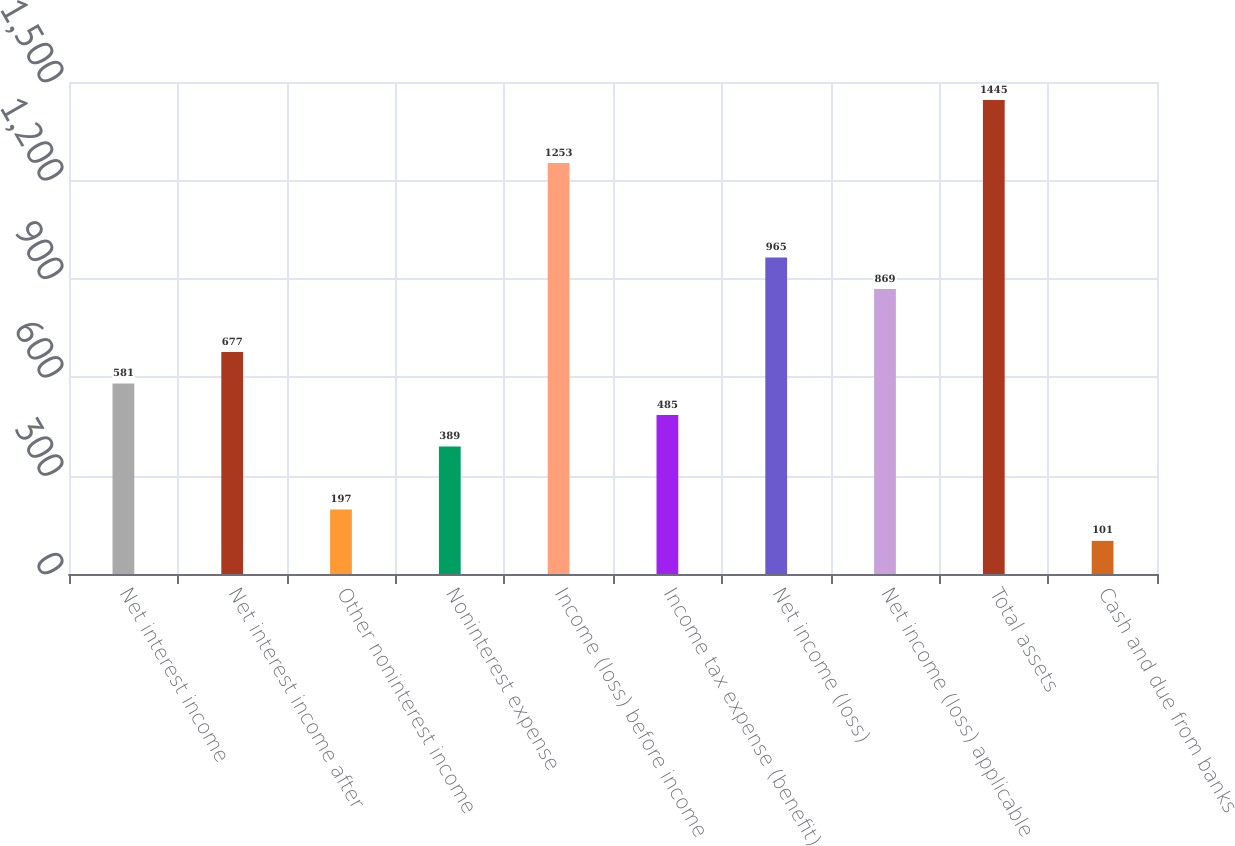Convert chart. <chart><loc_0><loc_0><loc_500><loc_500><bar_chart><fcel>Net interest income<fcel>Net interest income after<fcel>Other noninterest income<fcel>Noninterest expense<fcel>Income (loss) before income<fcel>Income tax expense (benefit)<fcel>Net income (loss)<fcel>Net income (loss) applicable<fcel>Total assets<fcel>Cash and due from banks<nl><fcel>581<fcel>677<fcel>197<fcel>389<fcel>1253<fcel>485<fcel>965<fcel>869<fcel>1445<fcel>101<nl></chart> 